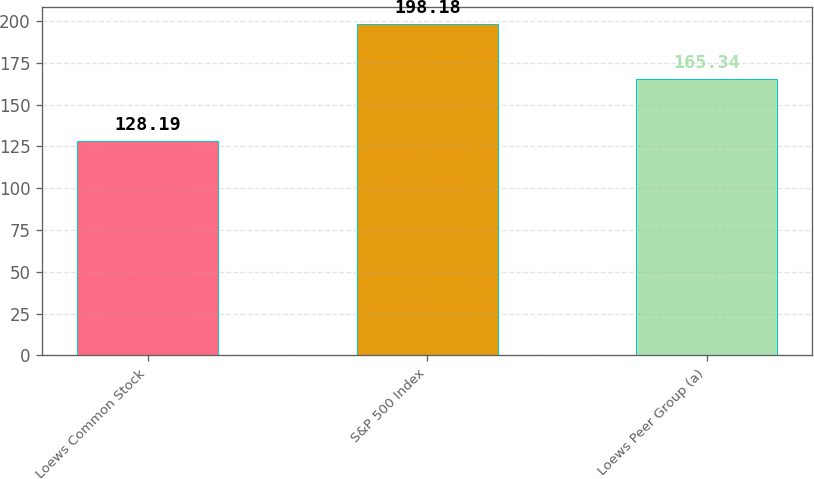Convert chart. <chart><loc_0><loc_0><loc_500><loc_500><bar_chart><fcel>Loews Common Stock<fcel>S&P 500 Index<fcel>Loews Peer Group (a)<nl><fcel>128.19<fcel>198.18<fcel>165.34<nl></chart> 